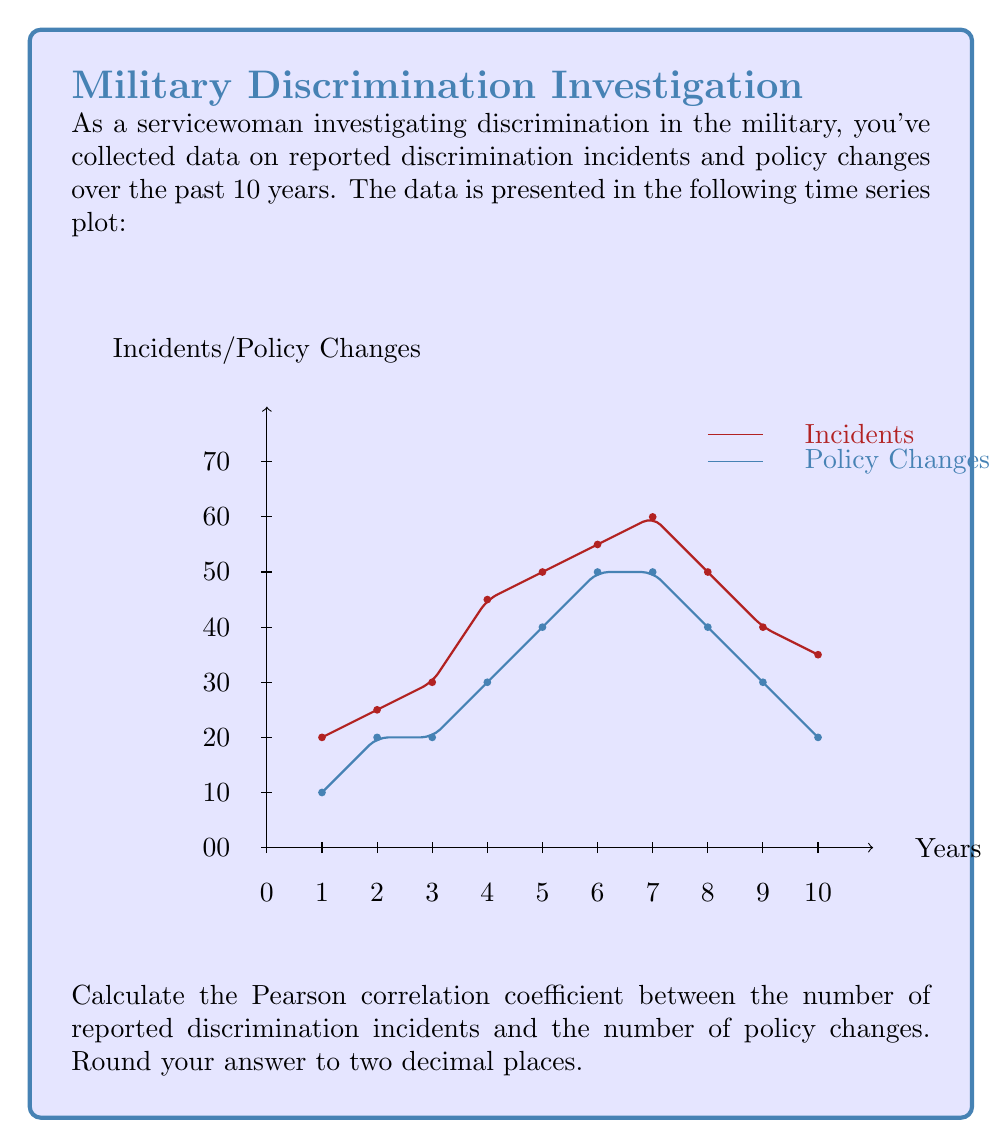Teach me how to tackle this problem. To calculate the Pearson correlation coefficient, we'll follow these steps:

1. Calculate the means of both variables:

   $\bar{X} = \frac{\sum_{i=1}^{n} X_i}{n}$ (for incidents)
   $\bar{Y} = \frac{\sum_{i=1}^{n} Y_i}{n}$ (for policy changes)

2. Calculate the deviations from the mean for each variable.

3. Calculate the product of the deviations.

4. Calculate the squared deviations for each variable.

5. Use the formula:

   $r = \frac{\sum_{i=1}^{n} (X_i - \bar{X})(Y_i - \bar{Y})}{\sqrt{\sum_{i=1}^{n} (X_i - \bar{X})^2 \sum_{i=1}^{n} (Y_i - \bar{Y})^2}}$

Let's proceed with the calculations:

1. Calculate means:
   $\bar{X} = \frac{20 + 25 + 30 + 45 + 50 + 55 + 60 + 50 + 40 + 35}{10} = 41$
   $\bar{Y} = \frac{1 + 2 + 2 + 3 + 4 + 5 + 5 + 4 + 3 + 2}{10} = 3.1$

2-4. Calculate deviations, products, and squared deviations:

   | Year | X  | Y | X - 41 | Y - 3.1 | (X - 41)(Y - 3.1) | (X - 41)² | (Y - 3.1)² |
   |------|----|----|--------|---------|-------------------|-----------|------------|
   | 1    | 20 | 1  | -21    | -2.1    | 44.1              | 441       | 4.41       |
   | 2    | 25 | 2  | -16    | -1.1    | 17.6              | 256       | 1.21       |
   | 3    | 30 | 2  | -11    | -1.1    | 12.1              | 121       | 1.21       |
   | 4    | 45 | 3  | 4      | -0.1    | -0.4              | 16        | 0.01       |
   | 5    | 50 | 4  | 9      | 0.9     | 8.1               | 81        | 0.81       |
   | 6    | 55 | 5  | 14     | 1.9     | 26.6              | 196       | 3.61       |
   | 7    | 60 | 5  | 19     | 1.9     | 36.1              | 361       | 3.61       |
   | 8    | 50 | 4  | 9      | 0.9     | 8.1               | 81        | 0.81       |
   | 9    | 40 | 3  | -1     | -0.1    | 0.1               | 1         | 0.01       |
   | 10   | 35 | 2  | -6     | -1.1    | 6.6               | 36        | 1.21       |
   | Sum  |    |    |        |         | 159               | 1590      | 16.9       |

5. Apply the formula:

   $r = \frac{159}{\sqrt{1590 \times 16.9}} = \frac{159}{\sqrt{26871}} = \frac{159}{163.92} \approx 0.9699$

Rounding to two decimal places, we get 0.97.
Answer: 0.97 